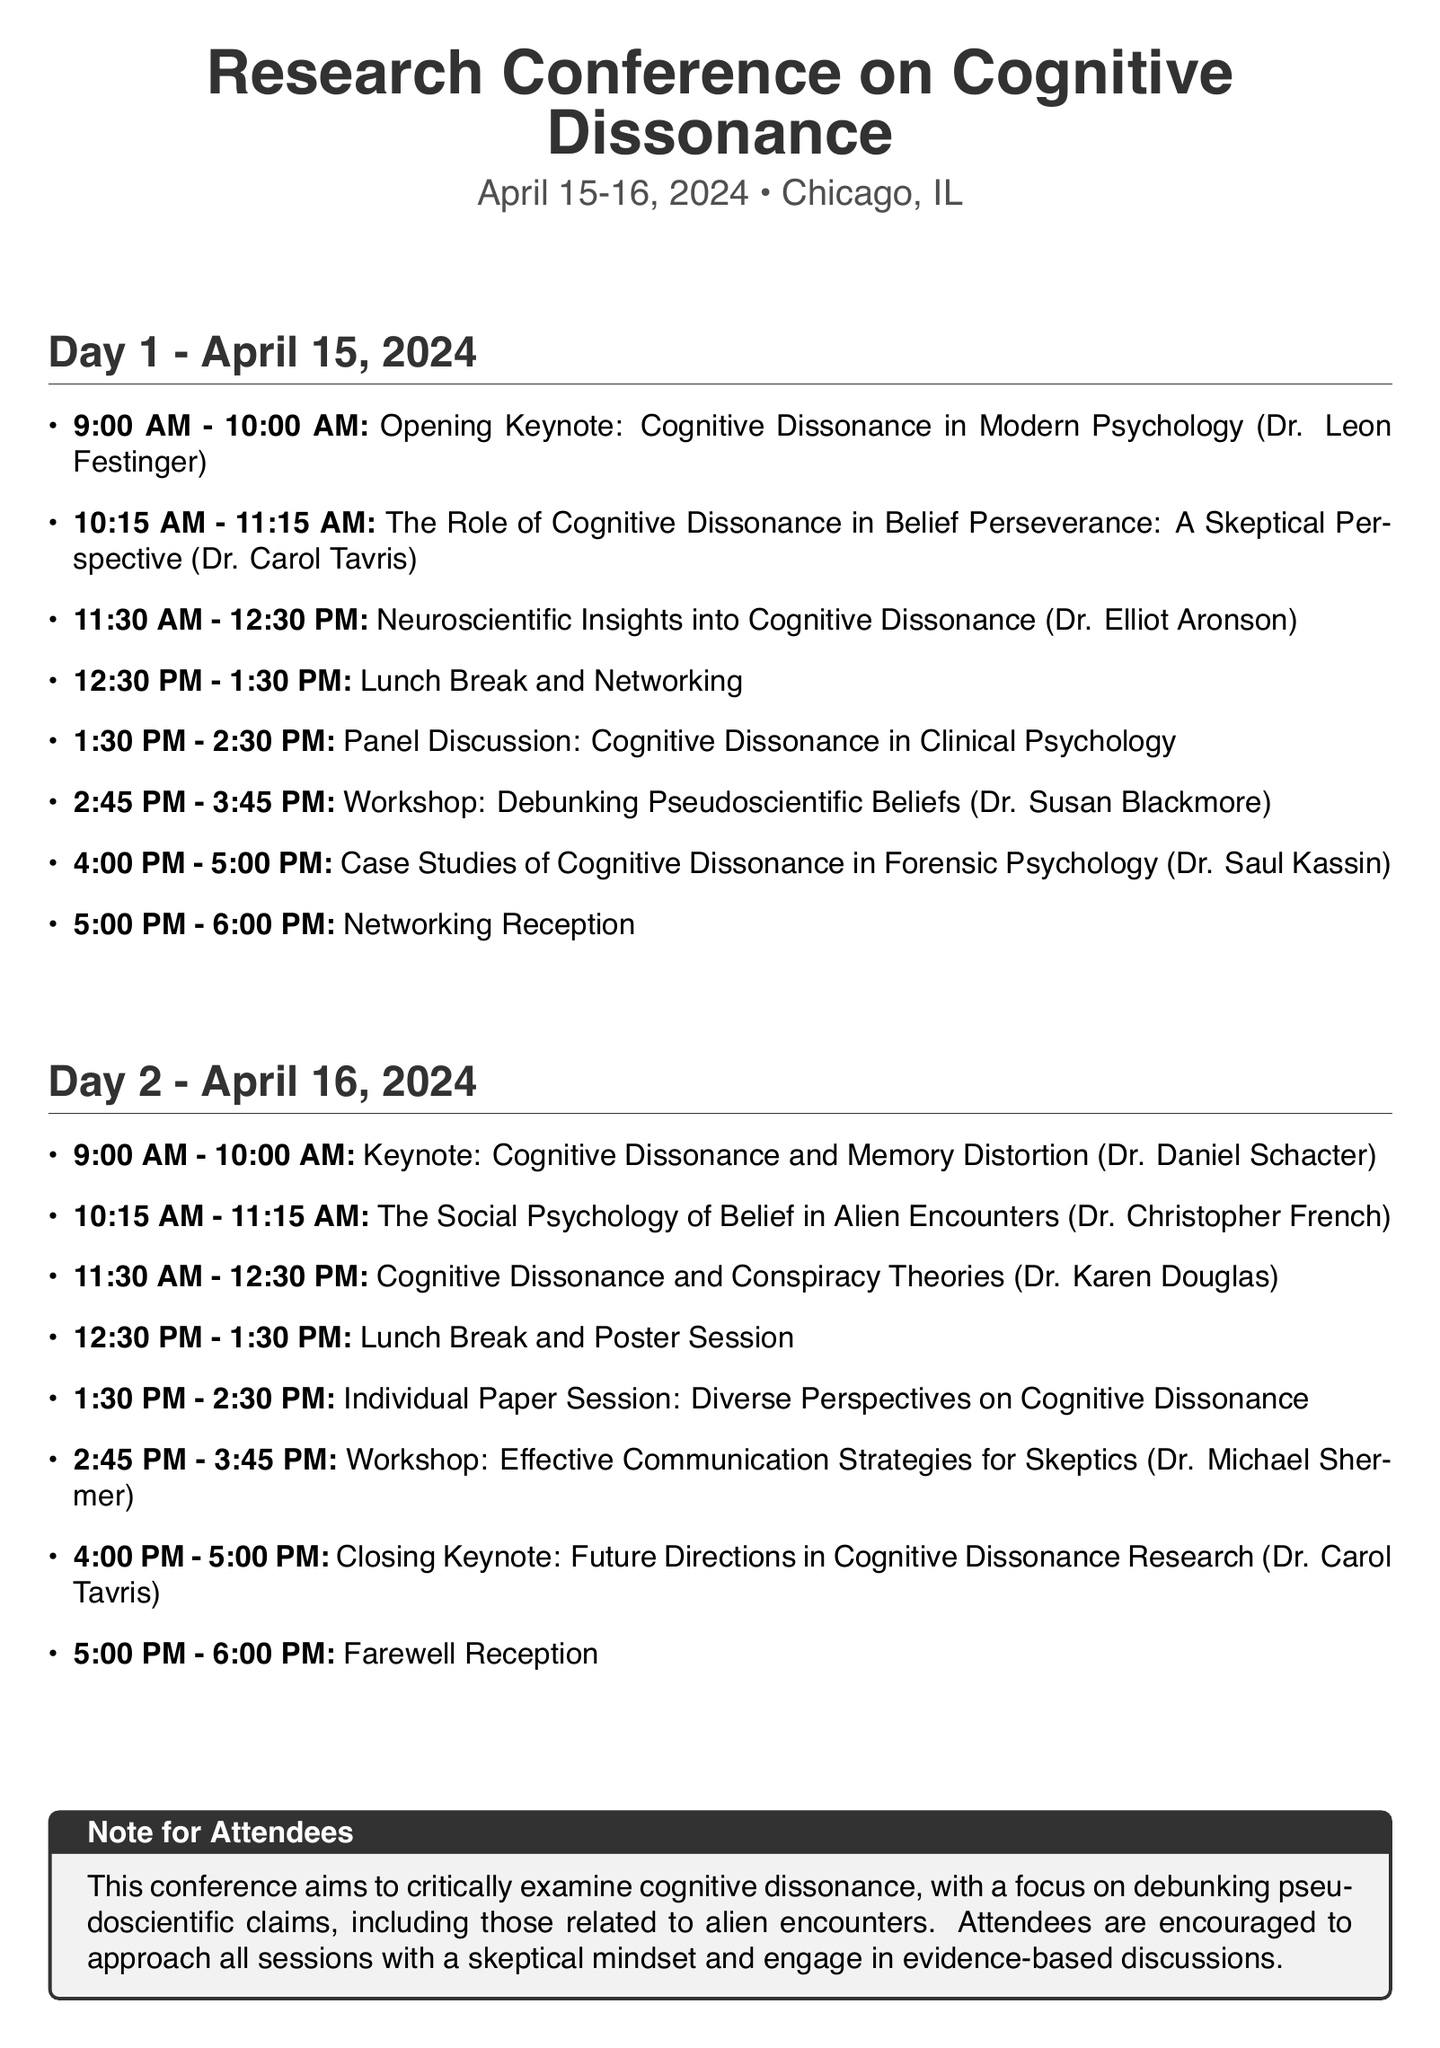what is the date of the conference? The document states the conference will take place on April 15-16, 2024.
Answer: April 15-16, 2024 who is the keynote speaker on the second day? The second day's keynote speaker is listed as Dr. Daniel Schacter.
Answer: Dr. Daniel Schacter how long is the lunch break on the second day? The lunch break's duration on the second day is indicated to be one hour, from 12:30 PM to 1:30 PM.
Answer: 1 hour which topic is covered by Dr. Christopher French? Dr. Christopher French is speaking on "The Social Psychology of Belief in Alien Encounters".
Answer: The Social Psychology of Belief in Alien Encounters what type of session is scheduled at 1:30 PM on the second day? The session at 1:30 PM on the second day is categorized as an "Individual Paper Session".
Answer: Individual Paper Session who will lead the workshop on effective communication strategies for skeptics? The document specifies that Dr. Michael Shermer will lead this workshop session.
Answer: Dr. Michael Shermer what is the main purpose of the conference? The note for attendees emphasizes that the conference aims to critically examine cognitive dissonance, focusing on debunking pseudoscientific claims.
Answer: Critically examine cognitive dissonance how many panel discussions are scheduled throughout the conference? The timetable includes one panel discussion scheduled on the first day.
Answer: 1 panel discussion 